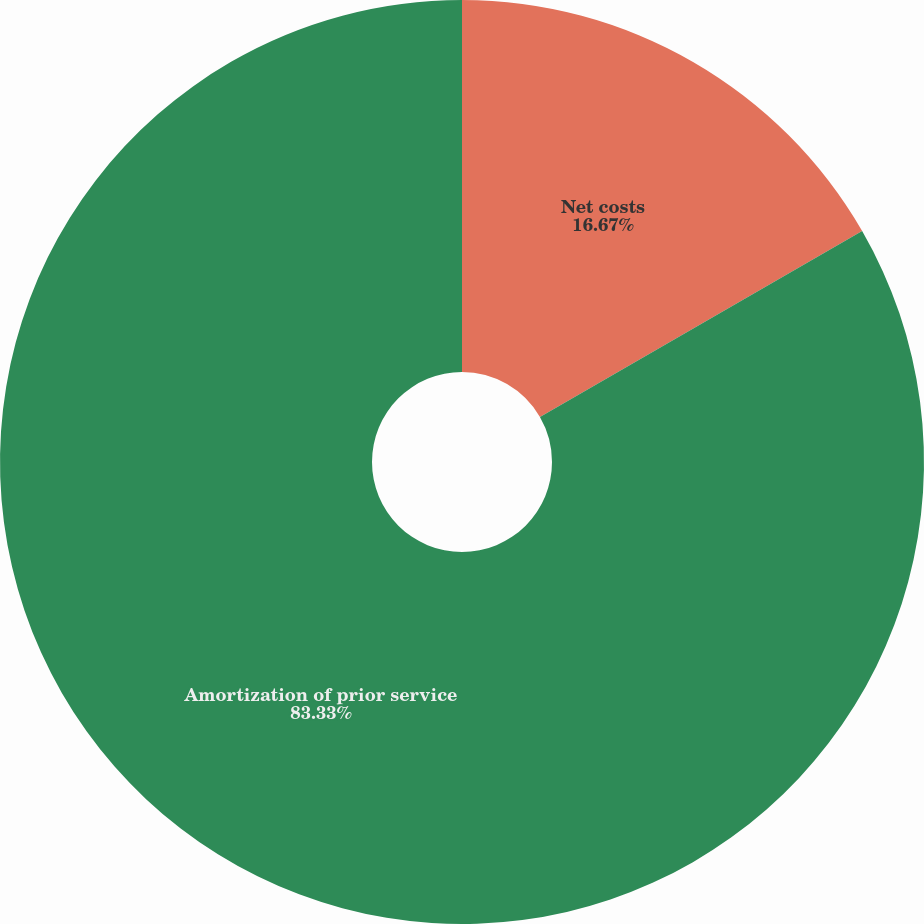Convert chart to OTSL. <chart><loc_0><loc_0><loc_500><loc_500><pie_chart><fcel>Net costs<fcel>Amortization of prior service<nl><fcel>16.67%<fcel>83.33%<nl></chart> 